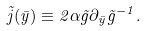<formula> <loc_0><loc_0><loc_500><loc_500>\tilde { j } ( \bar { y } ) \equiv 2 \alpha \tilde { g } \partial _ { \bar { y } } \tilde { g } ^ { - 1 } .</formula> 